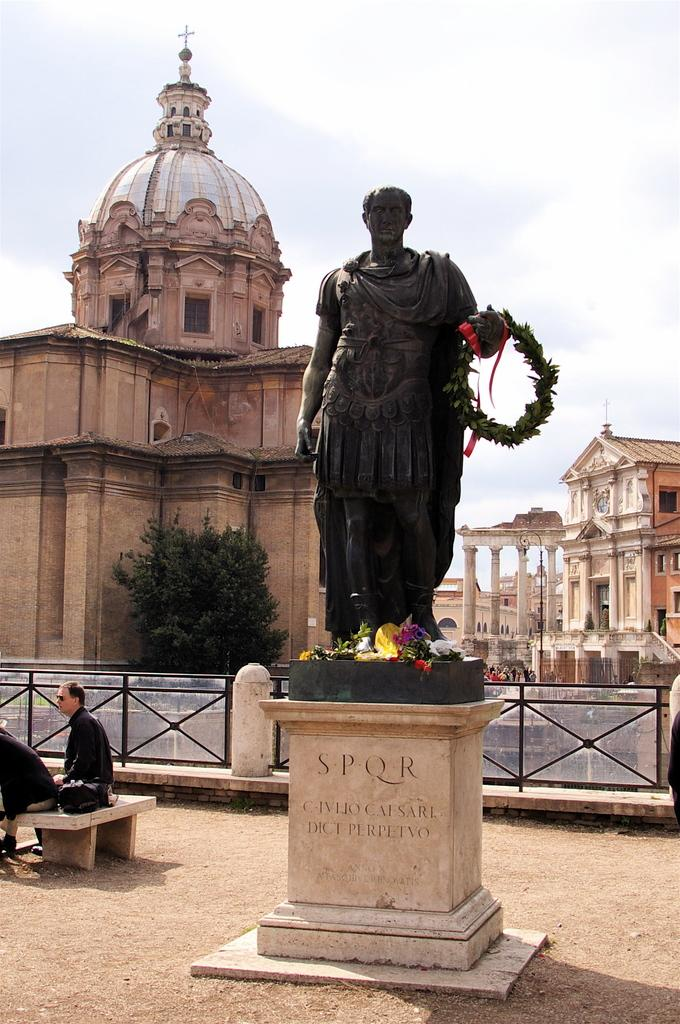What is the main subject in the image? There is a statue in the image. Can you describe the statue's appearance? The statue is black in color. What can be seen in the background of the image? There are two persons sitting in the background. What type of vegetation is present in the image? There are trees with green color in the image. What type of buildings can be seen in the image? There are buildings with cream color in the image. What is the color of the sky in the image? The sky appears to be white in color. What news is the spy delivering to the statue in the image? There is no spy or news present in the image; it features a statue, trees, buildings, and a sky. 